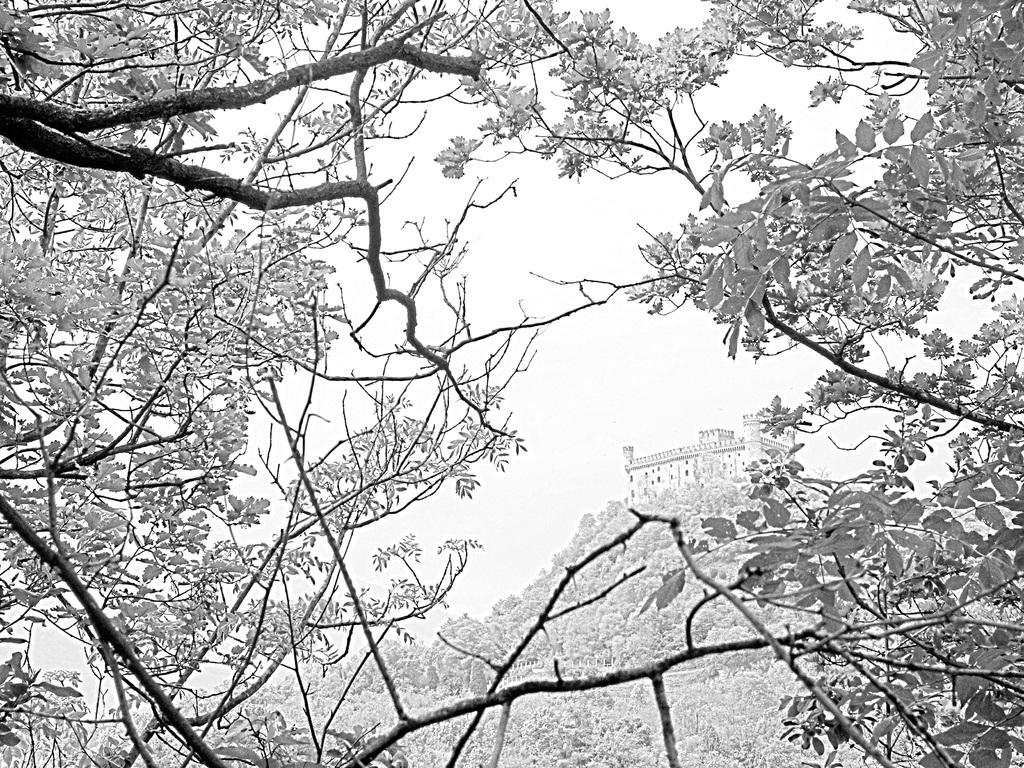What type of vegetation can be seen in the image? There are trees in the image. What structure is located in the middle of the image? There is a building in the middle of the image. What is the color scheme of the image? The image is in black and white. Where is the hook located in the image? There is no hook present in the image. What type of bulb is illuminating the building in the image? The image is in black and white, so it is not possible to determine the type of bulb illuminating the building. What picture is hanging on the wall in the image? There is no picture hanging on the wall in the image. 